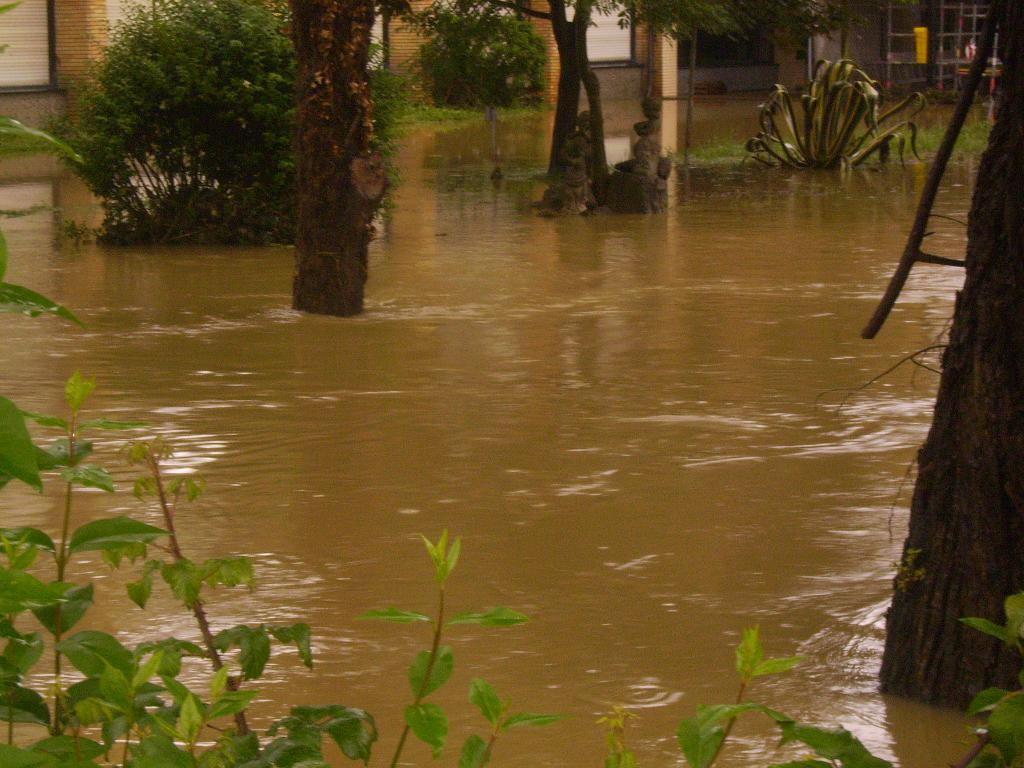What type of vegetation is in the front of the image? There are plants in the front of the image. What is located in the center of the image? There is water in the center of the image. What other type of vegetation can be seen in the image? There are trees in the image. What can be seen in the background of the image? There are buildings, grass, and a stand in the background of the image. Can you see any cracks in the water in the image? There are no cracks visible in the water in the image. Is there a cactus present in the image? There is no cactus present in the image. 